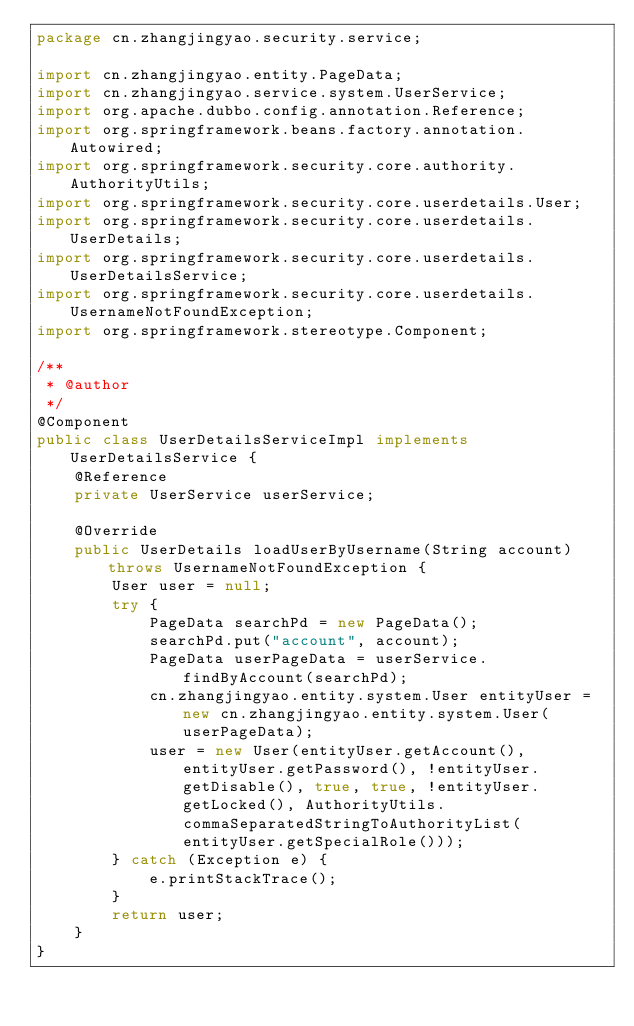<code> <loc_0><loc_0><loc_500><loc_500><_Java_>package cn.zhangjingyao.security.service;

import cn.zhangjingyao.entity.PageData;
import cn.zhangjingyao.service.system.UserService;
import org.apache.dubbo.config.annotation.Reference;
import org.springframework.beans.factory.annotation.Autowired;
import org.springframework.security.core.authority.AuthorityUtils;
import org.springframework.security.core.userdetails.User;
import org.springframework.security.core.userdetails.UserDetails;
import org.springframework.security.core.userdetails.UserDetailsService;
import org.springframework.security.core.userdetails.UsernameNotFoundException;
import org.springframework.stereotype.Component;

/**
 * @author
 */
@Component
public class UserDetailsServiceImpl implements UserDetailsService {
    @Reference
    private UserService userService;

    @Override
    public UserDetails loadUserByUsername(String account) throws UsernameNotFoundException {
        User user = null;
        try {
            PageData searchPd = new PageData();
            searchPd.put("account", account);
            PageData userPageData = userService.findByAccount(searchPd);
            cn.zhangjingyao.entity.system.User entityUser = new cn.zhangjingyao.entity.system.User(userPageData);
            user = new User(entityUser.getAccount(), entityUser.getPassword(), !entityUser.getDisable(), true, true, !entityUser.getLocked(), AuthorityUtils.commaSeparatedStringToAuthorityList(entityUser.getSpecialRole()));
        } catch (Exception e) {
            e.printStackTrace();
        }
        return user;
    }
}
</code> 